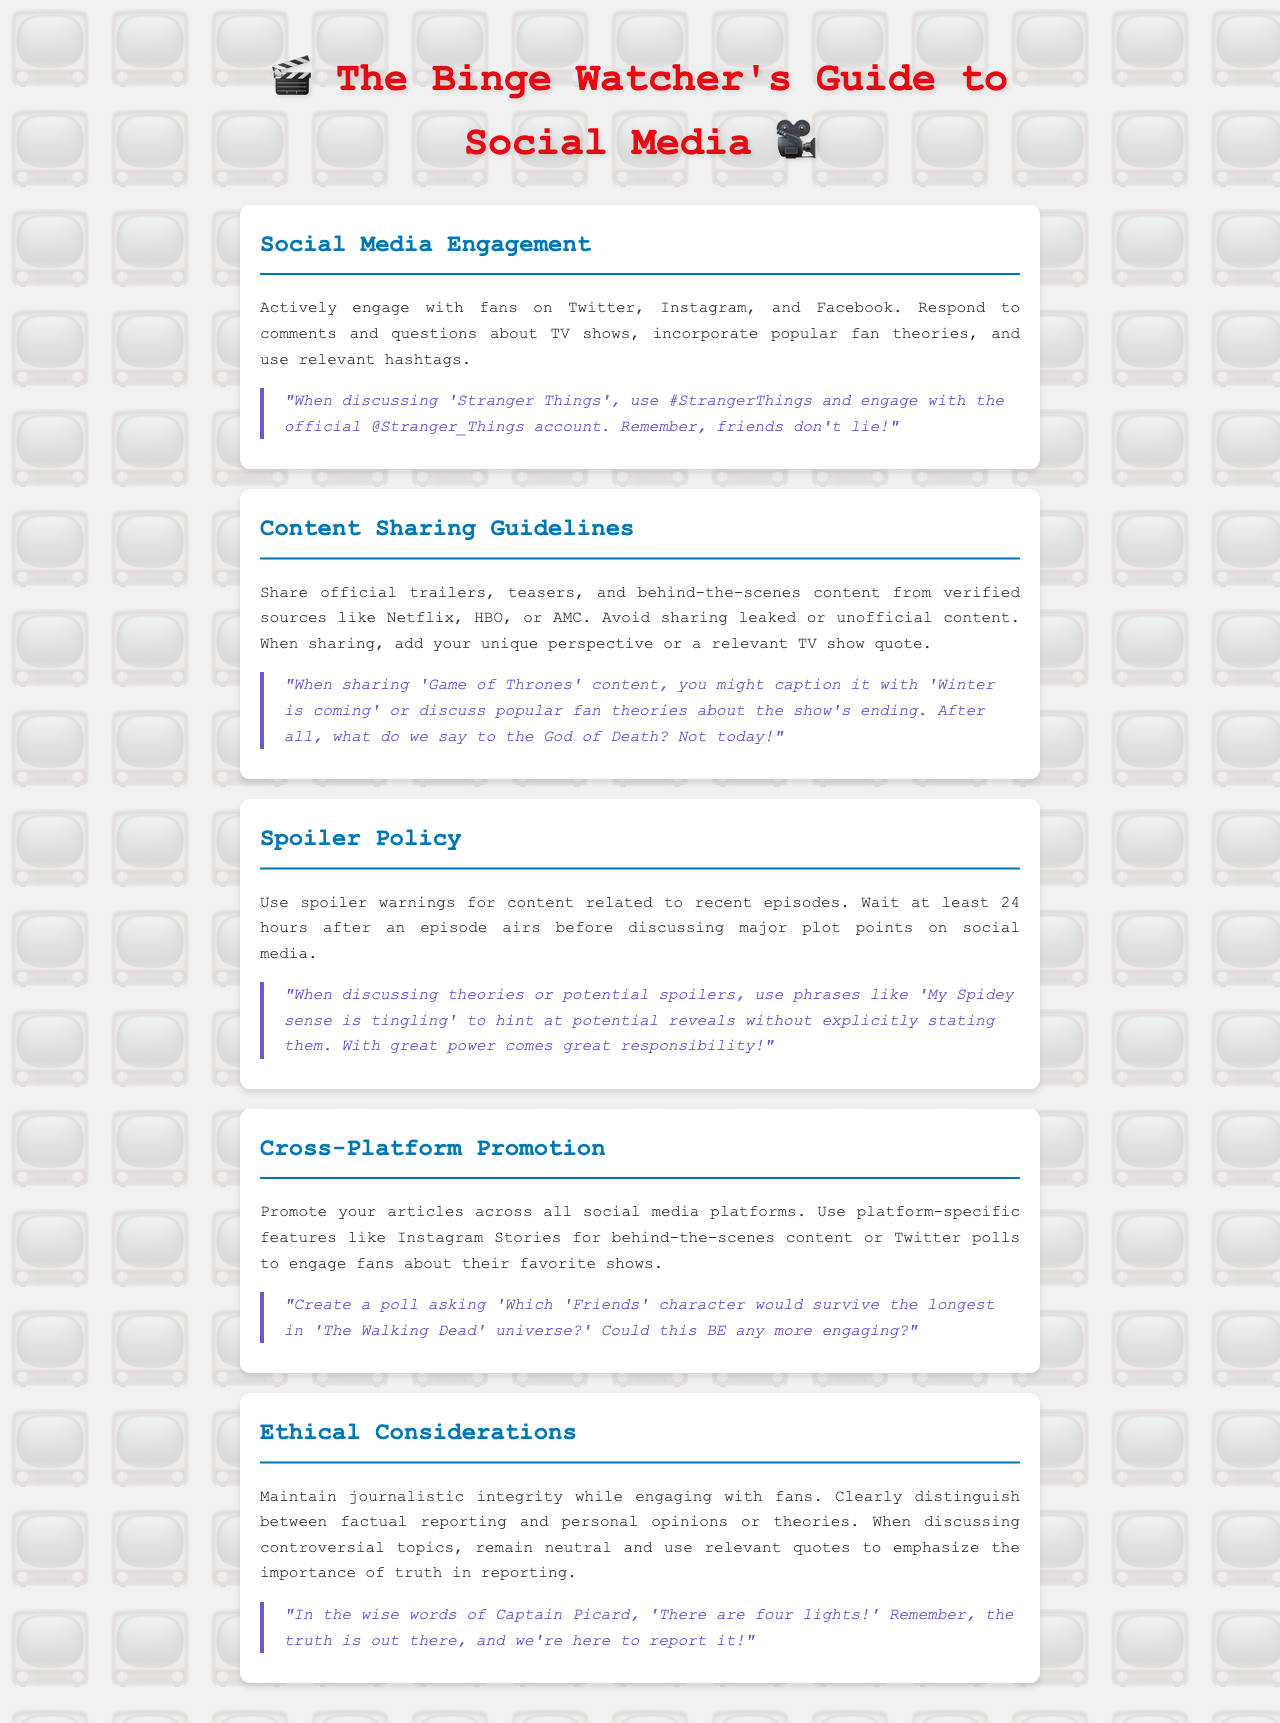What is the title of the document? The title is stated at the top of the document, introducing the main theme.
Answer: The Binge Watcher's Guide to Social Media What social media platforms should journalists engage on? The document specifies the main platforms where engagement should happen.
Answer: Twitter, Instagram, and Facebook What should be included when sharing official content? The guideline details what kind of content can be shared and how to enhance it.
Answer: Your unique perspective or a relevant TV show quote How long should you wait to discuss major plot points after an episode airs? The spoiler policy outlines the waiting period before discussing major plot points.
Answer: 24 hours What quote is suggested when discussing theories or potential spoilers? The document includes a specific phrase to hint at spoilers without direct statements.
Answer: My Spidey sense is tingling What is the ethical reminder for journalists when engaging with fans? The ethical section emphasizes the importance of maintaining integrity in reporting.
Answer: Maintain journalistic integrity Which character poll is suggested in the cross-platform promotion section? The document gives a specific idea for an engaging poll connecting two different shows.
Answer: Which 'Friends' character would survive the longest in 'The Walking Dead' universe? What must be used for content about recent episodes? The spoiler policy specifies how to treat content related to recent episodes.
Answer: Spoiler warnings What term is used for the audience engagement approach mentioned in the document? The section on engaging with fans describes a key strategy termed here.
Answer: Social Media Engagement 